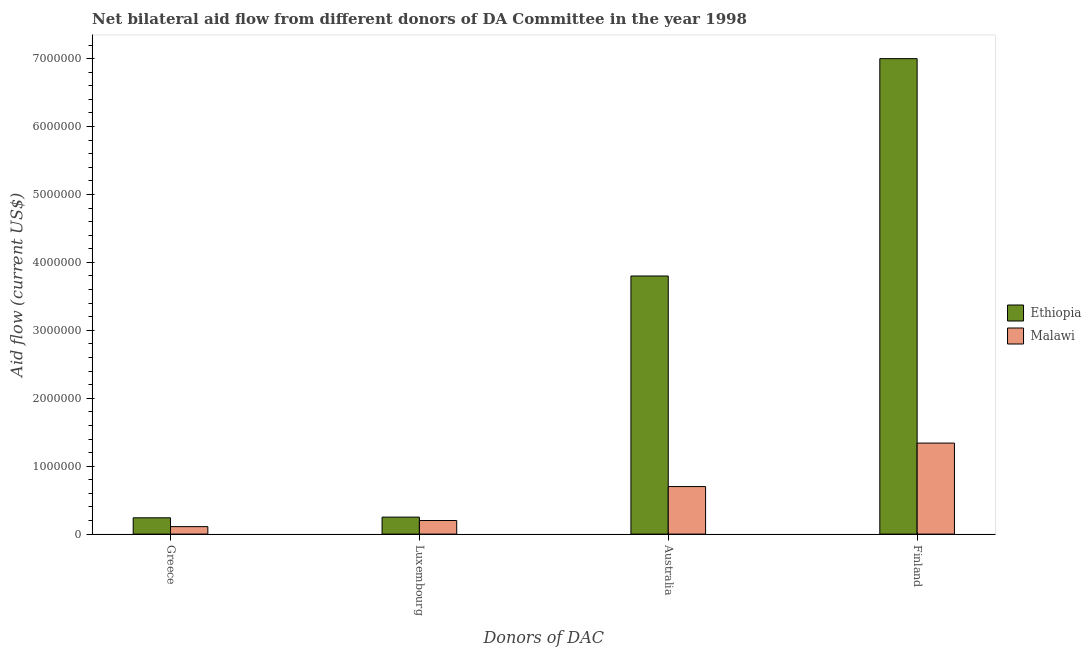How many groups of bars are there?
Keep it short and to the point. 4. Are the number of bars on each tick of the X-axis equal?
Give a very brief answer. Yes. What is the label of the 4th group of bars from the left?
Give a very brief answer. Finland. What is the amount of aid given by greece in Malawi?
Give a very brief answer. 1.10e+05. Across all countries, what is the maximum amount of aid given by australia?
Your response must be concise. 3.80e+06. Across all countries, what is the minimum amount of aid given by luxembourg?
Provide a succinct answer. 2.00e+05. In which country was the amount of aid given by luxembourg maximum?
Make the answer very short. Ethiopia. In which country was the amount of aid given by finland minimum?
Your response must be concise. Malawi. What is the total amount of aid given by luxembourg in the graph?
Give a very brief answer. 4.50e+05. What is the difference between the amount of aid given by luxembourg in Ethiopia and that in Malawi?
Your response must be concise. 5.00e+04. What is the difference between the amount of aid given by finland in Ethiopia and the amount of aid given by luxembourg in Malawi?
Provide a short and direct response. 6.80e+06. What is the average amount of aid given by greece per country?
Offer a terse response. 1.75e+05. What is the difference between the amount of aid given by greece and amount of aid given by luxembourg in Malawi?
Make the answer very short. -9.00e+04. What is the ratio of the amount of aid given by greece in Ethiopia to that in Malawi?
Offer a very short reply. 2.18. Is the amount of aid given by greece in Ethiopia less than that in Malawi?
Keep it short and to the point. No. Is the difference between the amount of aid given by australia in Malawi and Ethiopia greater than the difference between the amount of aid given by luxembourg in Malawi and Ethiopia?
Make the answer very short. No. What is the difference between the highest and the second highest amount of aid given by greece?
Your answer should be compact. 1.30e+05. What is the difference between the highest and the lowest amount of aid given by australia?
Make the answer very short. 3.10e+06. What does the 1st bar from the left in Australia represents?
Your answer should be very brief. Ethiopia. What does the 2nd bar from the right in Australia represents?
Your answer should be compact. Ethiopia. How many bars are there?
Give a very brief answer. 8. Are all the bars in the graph horizontal?
Your answer should be very brief. No. What is the difference between two consecutive major ticks on the Y-axis?
Keep it short and to the point. 1.00e+06. Does the graph contain any zero values?
Make the answer very short. No. What is the title of the graph?
Your answer should be compact. Net bilateral aid flow from different donors of DA Committee in the year 1998. What is the label or title of the X-axis?
Provide a succinct answer. Donors of DAC. What is the label or title of the Y-axis?
Ensure brevity in your answer.  Aid flow (current US$). What is the Aid flow (current US$) in Ethiopia in Luxembourg?
Keep it short and to the point. 2.50e+05. What is the Aid flow (current US$) in Malawi in Luxembourg?
Your answer should be compact. 2.00e+05. What is the Aid flow (current US$) in Ethiopia in Australia?
Give a very brief answer. 3.80e+06. What is the Aid flow (current US$) in Malawi in Finland?
Offer a terse response. 1.34e+06. Across all Donors of DAC, what is the maximum Aid flow (current US$) in Malawi?
Provide a short and direct response. 1.34e+06. What is the total Aid flow (current US$) in Ethiopia in the graph?
Make the answer very short. 1.13e+07. What is the total Aid flow (current US$) of Malawi in the graph?
Keep it short and to the point. 2.35e+06. What is the difference between the Aid flow (current US$) of Ethiopia in Greece and that in Australia?
Your answer should be compact. -3.56e+06. What is the difference between the Aid flow (current US$) in Malawi in Greece and that in Australia?
Your answer should be compact. -5.90e+05. What is the difference between the Aid flow (current US$) in Ethiopia in Greece and that in Finland?
Your response must be concise. -6.76e+06. What is the difference between the Aid flow (current US$) of Malawi in Greece and that in Finland?
Your answer should be compact. -1.23e+06. What is the difference between the Aid flow (current US$) in Ethiopia in Luxembourg and that in Australia?
Your response must be concise. -3.55e+06. What is the difference between the Aid flow (current US$) of Malawi in Luxembourg and that in Australia?
Your response must be concise. -5.00e+05. What is the difference between the Aid flow (current US$) of Ethiopia in Luxembourg and that in Finland?
Your answer should be very brief. -6.75e+06. What is the difference between the Aid flow (current US$) in Malawi in Luxembourg and that in Finland?
Offer a very short reply. -1.14e+06. What is the difference between the Aid flow (current US$) in Ethiopia in Australia and that in Finland?
Your response must be concise. -3.20e+06. What is the difference between the Aid flow (current US$) of Malawi in Australia and that in Finland?
Offer a very short reply. -6.40e+05. What is the difference between the Aid flow (current US$) of Ethiopia in Greece and the Aid flow (current US$) of Malawi in Australia?
Give a very brief answer. -4.60e+05. What is the difference between the Aid flow (current US$) of Ethiopia in Greece and the Aid flow (current US$) of Malawi in Finland?
Offer a very short reply. -1.10e+06. What is the difference between the Aid flow (current US$) in Ethiopia in Luxembourg and the Aid flow (current US$) in Malawi in Australia?
Your response must be concise. -4.50e+05. What is the difference between the Aid flow (current US$) in Ethiopia in Luxembourg and the Aid flow (current US$) in Malawi in Finland?
Your answer should be very brief. -1.09e+06. What is the difference between the Aid flow (current US$) of Ethiopia in Australia and the Aid flow (current US$) of Malawi in Finland?
Keep it short and to the point. 2.46e+06. What is the average Aid flow (current US$) of Ethiopia per Donors of DAC?
Your answer should be very brief. 2.82e+06. What is the average Aid flow (current US$) of Malawi per Donors of DAC?
Provide a succinct answer. 5.88e+05. What is the difference between the Aid flow (current US$) in Ethiopia and Aid flow (current US$) in Malawi in Greece?
Your answer should be very brief. 1.30e+05. What is the difference between the Aid flow (current US$) in Ethiopia and Aid flow (current US$) in Malawi in Luxembourg?
Provide a short and direct response. 5.00e+04. What is the difference between the Aid flow (current US$) in Ethiopia and Aid flow (current US$) in Malawi in Australia?
Give a very brief answer. 3.10e+06. What is the difference between the Aid flow (current US$) of Ethiopia and Aid flow (current US$) of Malawi in Finland?
Provide a short and direct response. 5.66e+06. What is the ratio of the Aid flow (current US$) in Malawi in Greece to that in Luxembourg?
Give a very brief answer. 0.55. What is the ratio of the Aid flow (current US$) of Ethiopia in Greece to that in Australia?
Ensure brevity in your answer.  0.06. What is the ratio of the Aid flow (current US$) in Malawi in Greece to that in Australia?
Offer a very short reply. 0.16. What is the ratio of the Aid flow (current US$) in Ethiopia in Greece to that in Finland?
Offer a terse response. 0.03. What is the ratio of the Aid flow (current US$) in Malawi in Greece to that in Finland?
Offer a very short reply. 0.08. What is the ratio of the Aid flow (current US$) in Ethiopia in Luxembourg to that in Australia?
Provide a succinct answer. 0.07. What is the ratio of the Aid flow (current US$) of Malawi in Luxembourg to that in Australia?
Keep it short and to the point. 0.29. What is the ratio of the Aid flow (current US$) in Ethiopia in Luxembourg to that in Finland?
Provide a short and direct response. 0.04. What is the ratio of the Aid flow (current US$) in Malawi in Luxembourg to that in Finland?
Make the answer very short. 0.15. What is the ratio of the Aid flow (current US$) of Ethiopia in Australia to that in Finland?
Ensure brevity in your answer.  0.54. What is the ratio of the Aid flow (current US$) in Malawi in Australia to that in Finland?
Provide a short and direct response. 0.52. What is the difference between the highest and the second highest Aid flow (current US$) in Ethiopia?
Provide a short and direct response. 3.20e+06. What is the difference between the highest and the second highest Aid flow (current US$) in Malawi?
Ensure brevity in your answer.  6.40e+05. What is the difference between the highest and the lowest Aid flow (current US$) of Ethiopia?
Make the answer very short. 6.76e+06. What is the difference between the highest and the lowest Aid flow (current US$) in Malawi?
Your answer should be very brief. 1.23e+06. 